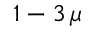Convert formula to latex. <formula><loc_0><loc_0><loc_500><loc_500>1 - 3 \, \mu</formula> 